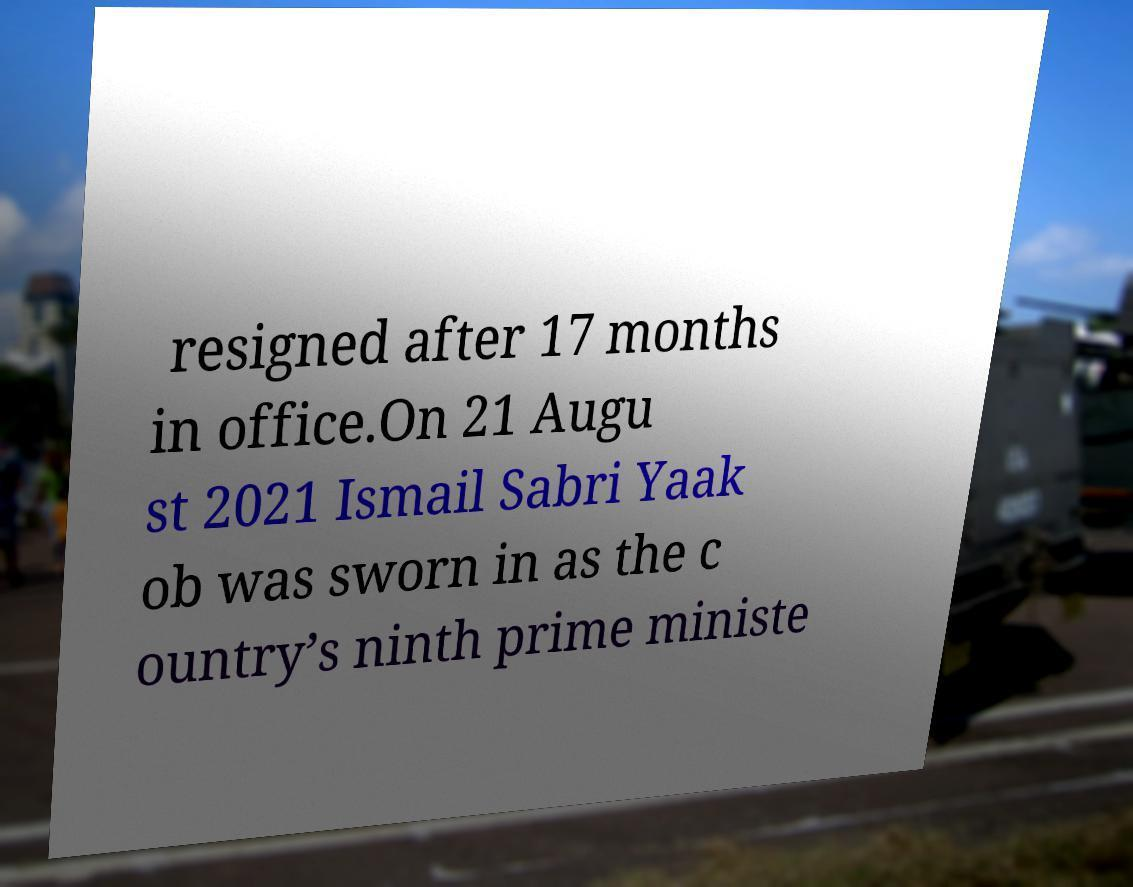What messages or text are displayed in this image? I need them in a readable, typed format. resigned after 17 months in office.On 21 Augu st 2021 Ismail Sabri Yaak ob was sworn in as the c ountry’s ninth prime ministe 